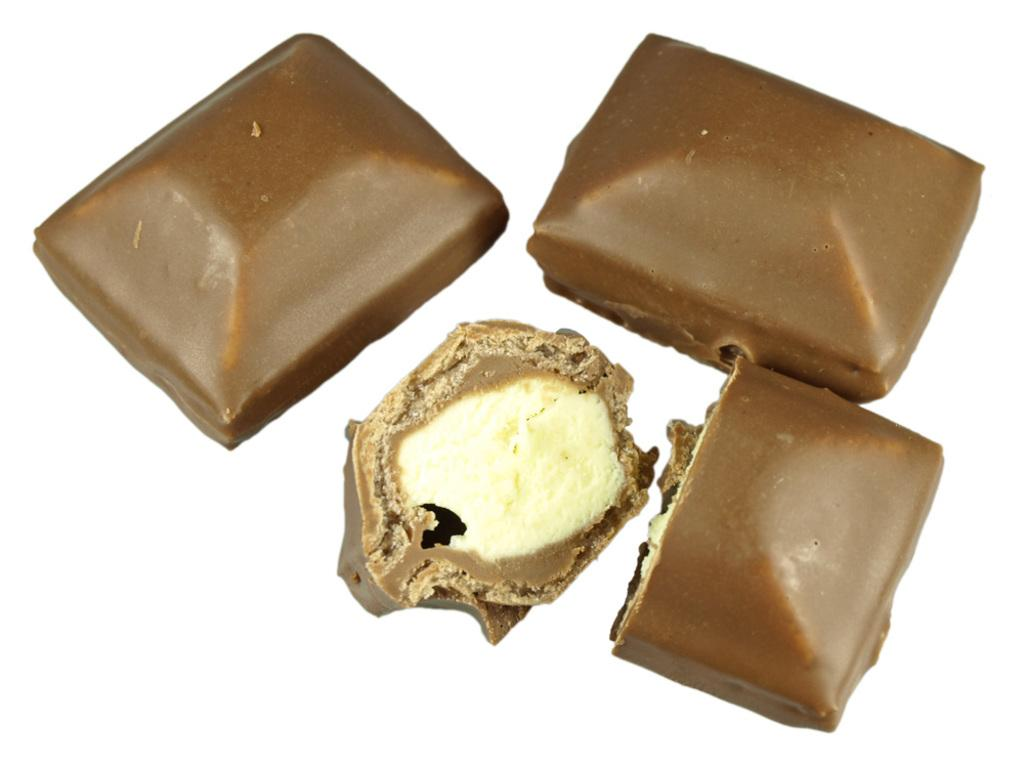What type of food is present in the image? There are chocolates in the image. What color are the chocolates? The chocolates are brown in color. What color is the background of the image? The background is white in color. What type of copper material can be seen in the image? There is no copper material present in the image; it features chocolates and a white background. How many toes are visible in the image? There are no toes visible in the image; it only contains chocolates and a white background. 